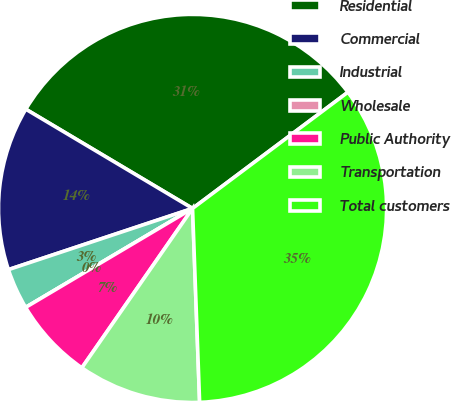Convert chart to OTSL. <chart><loc_0><loc_0><loc_500><loc_500><pie_chart><fcel>Residential<fcel>Commercial<fcel>Industrial<fcel>Wholesale<fcel>Public Authority<fcel>Transportation<fcel>Total customers<nl><fcel>31.23%<fcel>13.65%<fcel>3.41%<fcel>0.0%<fcel>6.82%<fcel>10.24%<fcel>34.64%<nl></chart> 